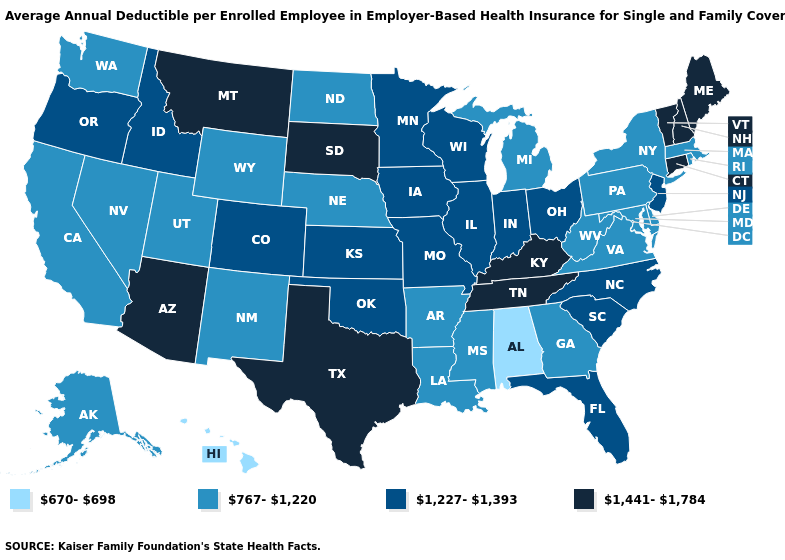Does Michigan have a higher value than Alabama?
Short answer required. Yes. Among the states that border Florida , which have the lowest value?
Write a very short answer. Alabama. Which states have the lowest value in the USA?
Answer briefly. Alabama, Hawaii. Among the states that border South Carolina , does Georgia have the highest value?
Write a very short answer. No. Does Alabama have the lowest value in the USA?
Write a very short answer. Yes. What is the value of Tennessee?
Short answer required. 1,441-1,784. Which states have the highest value in the USA?
Keep it brief. Arizona, Connecticut, Kentucky, Maine, Montana, New Hampshire, South Dakota, Tennessee, Texas, Vermont. Does Alabama have a lower value than Kentucky?
Give a very brief answer. Yes. What is the highest value in the South ?
Concise answer only. 1,441-1,784. How many symbols are there in the legend?
Concise answer only. 4. Name the states that have a value in the range 1,227-1,393?
Concise answer only. Colorado, Florida, Idaho, Illinois, Indiana, Iowa, Kansas, Minnesota, Missouri, New Jersey, North Carolina, Ohio, Oklahoma, Oregon, South Carolina, Wisconsin. Which states have the highest value in the USA?
Short answer required. Arizona, Connecticut, Kentucky, Maine, Montana, New Hampshire, South Dakota, Tennessee, Texas, Vermont. Which states hav the highest value in the South?
Keep it brief. Kentucky, Tennessee, Texas. How many symbols are there in the legend?
Quick response, please. 4. What is the value of Massachusetts?
Keep it brief. 767-1,220. 